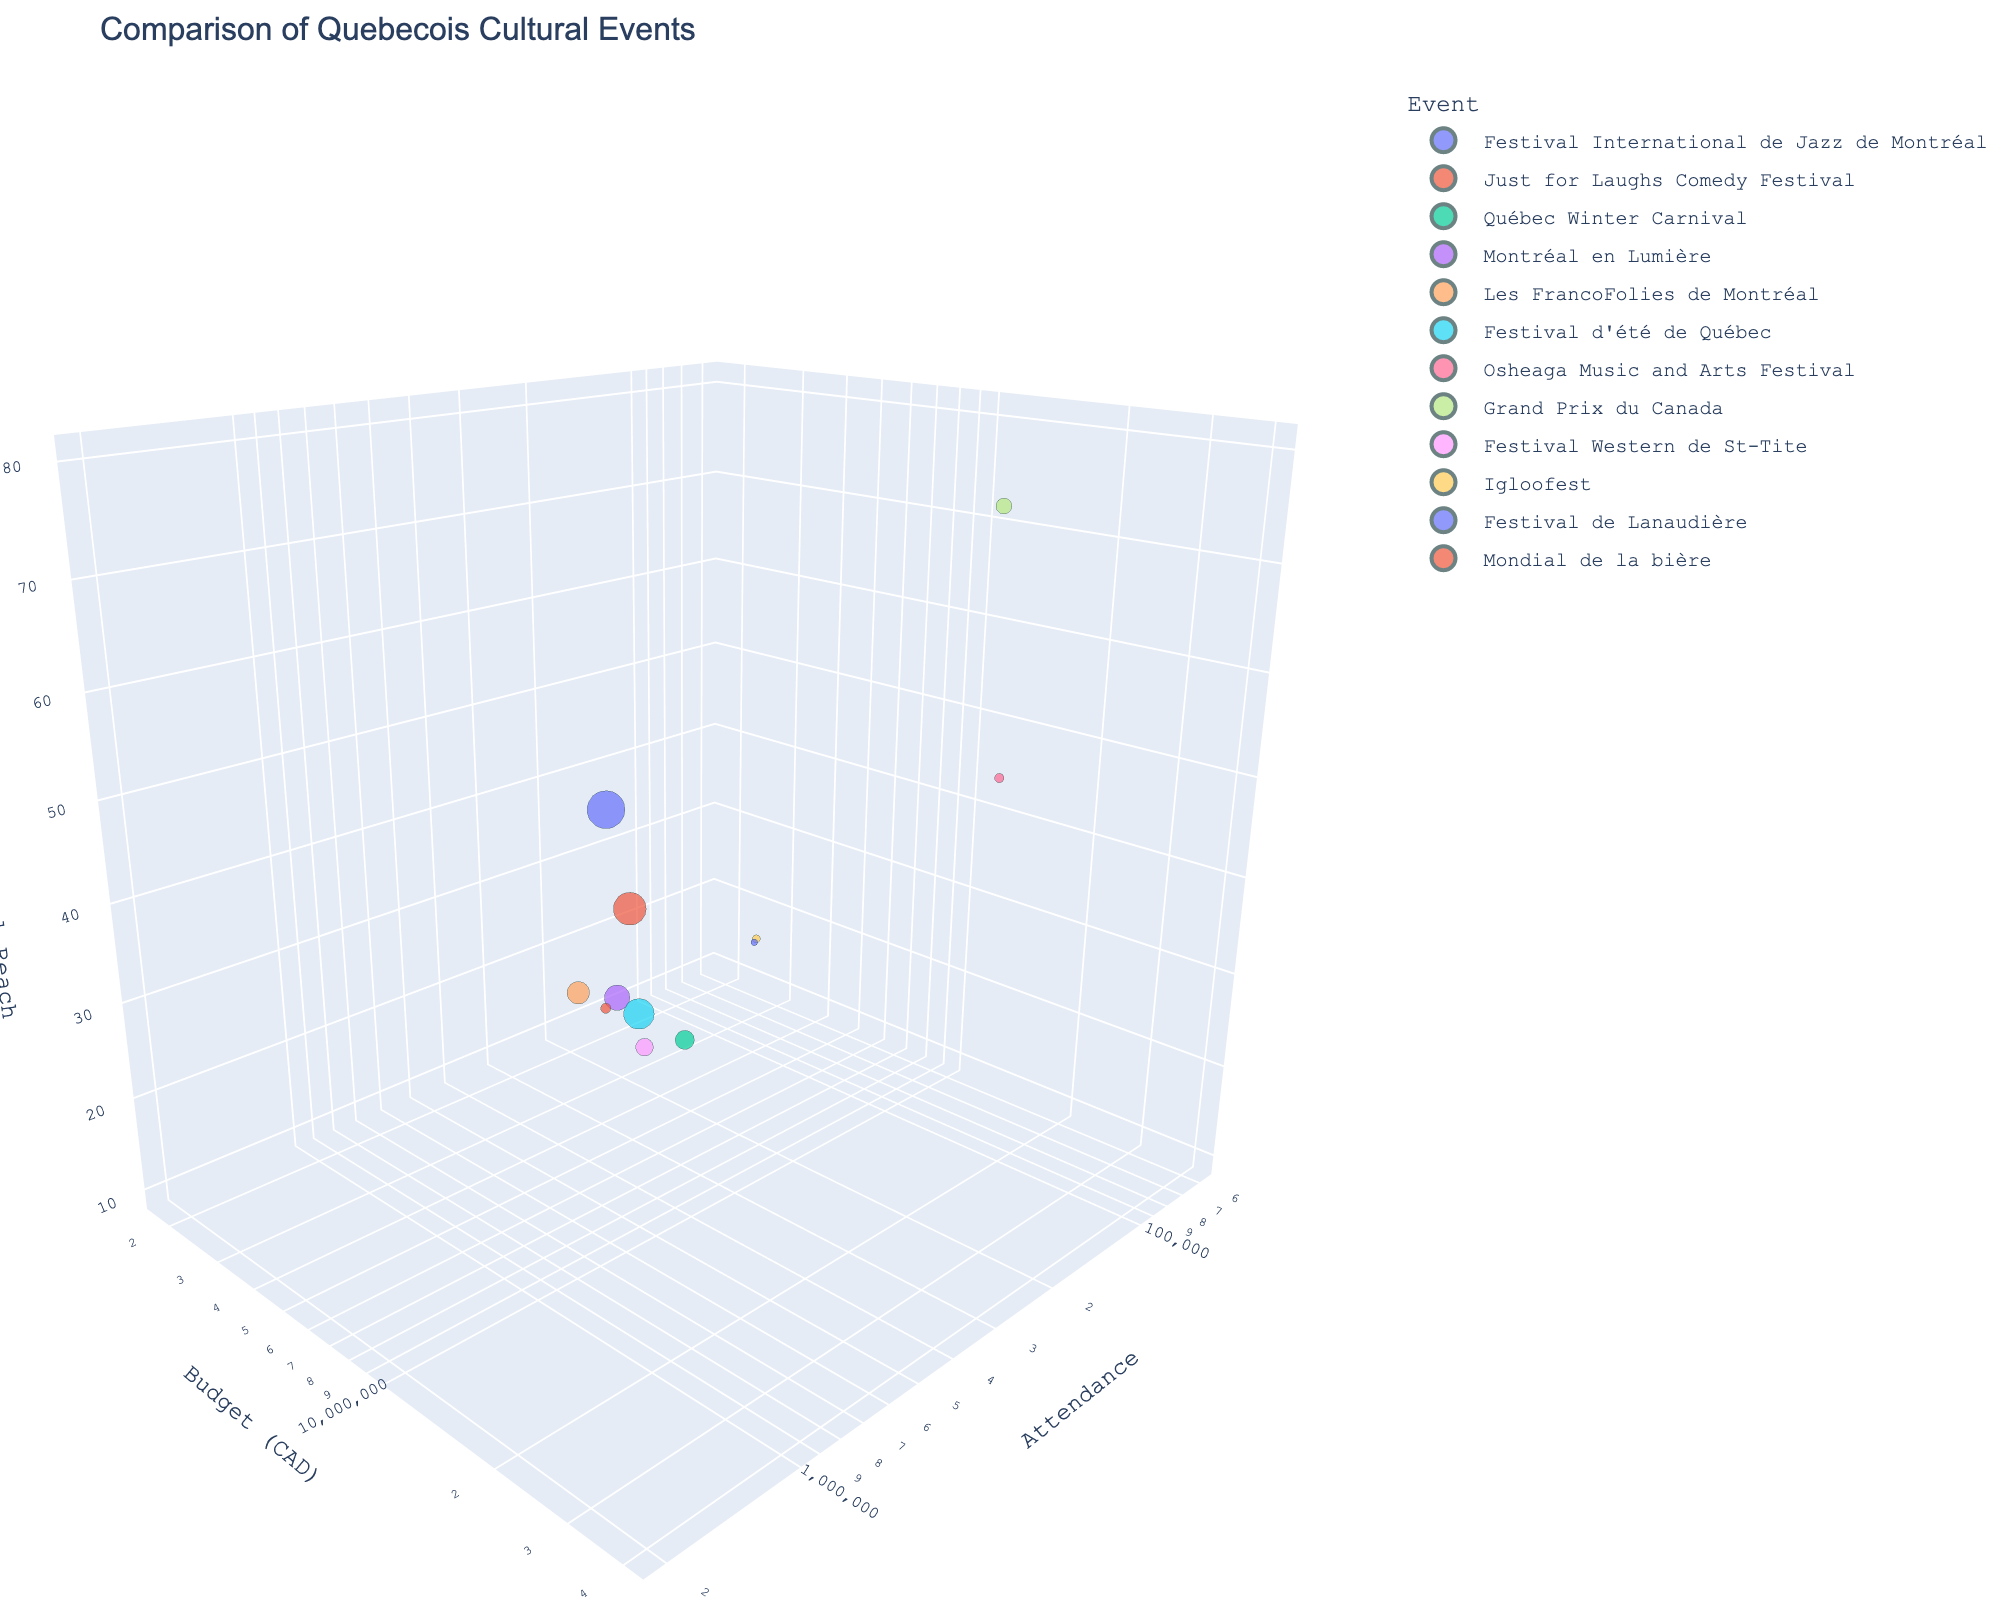How many events are represented in the figure? The title and legend indicate that each event is represented by a unique color, so by counting the distinct colors in the plot or counting the entries in the legend, we can determine the number of events.
Answer: 12 What is the title of the plot? The title of the plot is typically displayed at the top center of the figure.
Answer: Comparison of Quebecois Cultural Events Which event has the highest budget allocation? By examining the y-axis (Budget (CAD)) and finding the highest value, then identifying the corresponding event from the color and hover information, we can determine the event with the highest budget.
Answer: Grand Prix du Canada Which event has the lowest international reach? The z-axis represents International Reach. By identifying the data point closest to the lowest value on this axis and using the color and hover information, we can determine the event.
Answer: Mondial de la bière Which event has the largest attendance? The size of the markers in the 3D scatter plot represents attendance. The largest marker corresponds to the event with the largest attendance, which can be verified by hovering over the marker to see the exact attendance number.
Answer: Festival International de Jazz de Montréal What is the difference in budget between the event with the highest budget and the lowest budget? The highest budget is for the Grand Prix du Canada (40,000,000 CAD) and the lowest budget is for the Mondial de la bière (1,800,000 CAD). The difference can be calculated as 40,000,000 - 1,800,000.
Answer: 38,200,000 CAD Which event has the second-highest attendance? By examining the sizes of the markers and identifying the second-largest marker, we can determine the second-highest attendance, and then verify by hovering over the marker.
Answer: Just for Laughs Comedy Festival Which event has both medium attendance and budget with high international reach? Identify the event with attendance and budget values in the middle range on the x and y axes, respectively, but with a high value on the z-axis for international reach. By cross-referencing these criteria with the hover information, we find the event.
Answer: Grand Prix du Canada Considering attendance, which event has a higher attendance, Festival Western de St-Tite or Igloofest? Compare the x-axis positions of the markers for Festival Western de St-Tite and Igloofest. The marker further to the right has higher attendance.
Answer: Festival Western de St-Tite What is the average international reach of the events? Sum the international reach values for all events and divide by the number of events: (65 + 55 + 30 + 40 + 35 + 45 + 50 + 80 + 25 + 20 + 15 + 10) / 12. Detailed calculation: (65+55+30+40+35+45+50+80+25+20+15+10) = 470, so the average is 470/12.
Answer: 39 